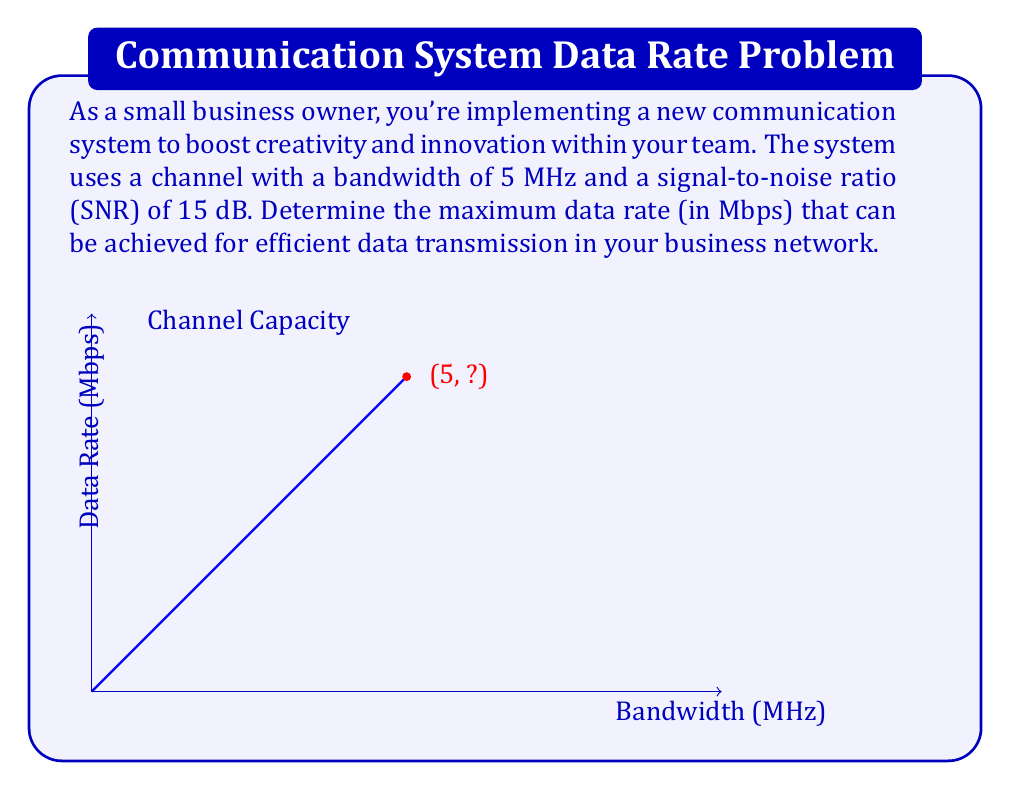Can you solve this math problem? To solve this problem, we'll use the Shannon-Hartley theorem, which gives the channel capacity for a communication channel with Gaussian noise. The steps are as follows:

1) The Shannon-Hartley theorem states that the channel capacity $C$ is:

   $$C = B \log_2(1 + SNR)$$

   where $B$ is the bandwidth in Hz, and SNR is the signal-to-noise ratio.

2) We're given:
   - Bandwidth $B = 5$ MHz = $5 \times 10^6$ Hz
   - SNR = 15 dB

3) We need to convert the SNR from dB to a linear scale:
   $$SNR_{linear} = 10^{SNR_{dB}/10} = 10^{15/10} = 10^{1.5} \approx 31.6228$$

4) Now we can plug these values into the Shannon-Hartley equation:

   $$C = (5 \times 10^6) \log_2(1 + 31.6228)$$

5) Simplify:
   $$C = 5 \times 10^6 \times \log_2(32.6228)$$
   $$C = 5 \times 10^6 \times 5.0280$$
   $$C = 25.14 \times 10^6 \text{ bits per second}$$

6) Convert to Mbps:
   $$C = 25.14 \text{ Mbps}$$

This represents the theoretical maximum data rate for efficient data transmission in your business network under the given conditions.
Answer: 25.14 Mbps 